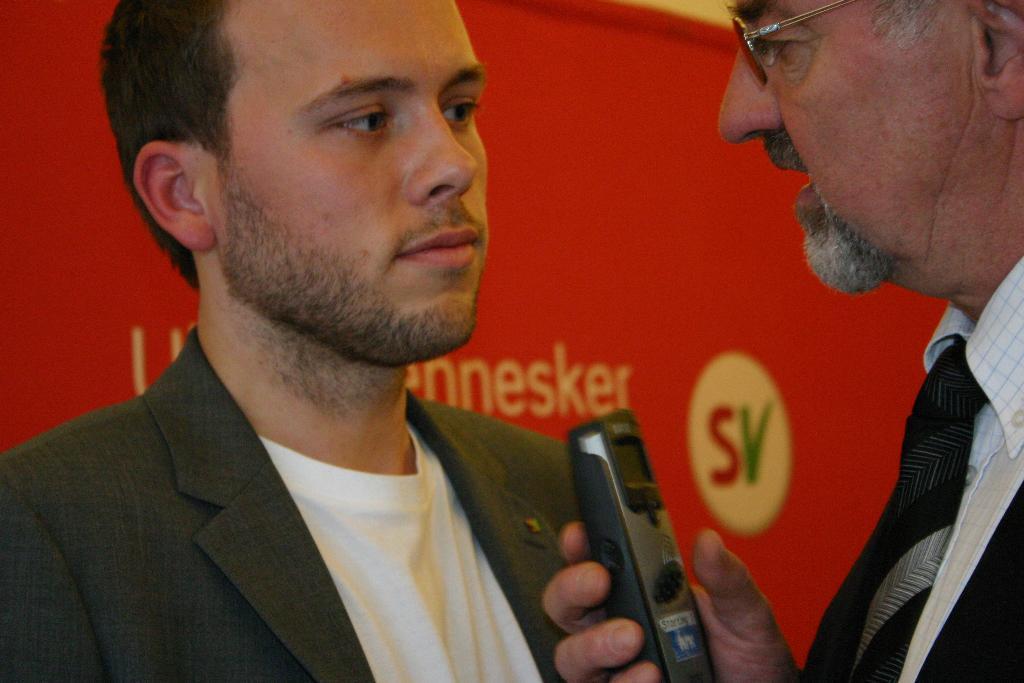Describe this image in one or two sentences. In this image I can see two persons. In front the person is wearing white color shirt and black color tie and holding some object. In the background I can see the board in red color. 